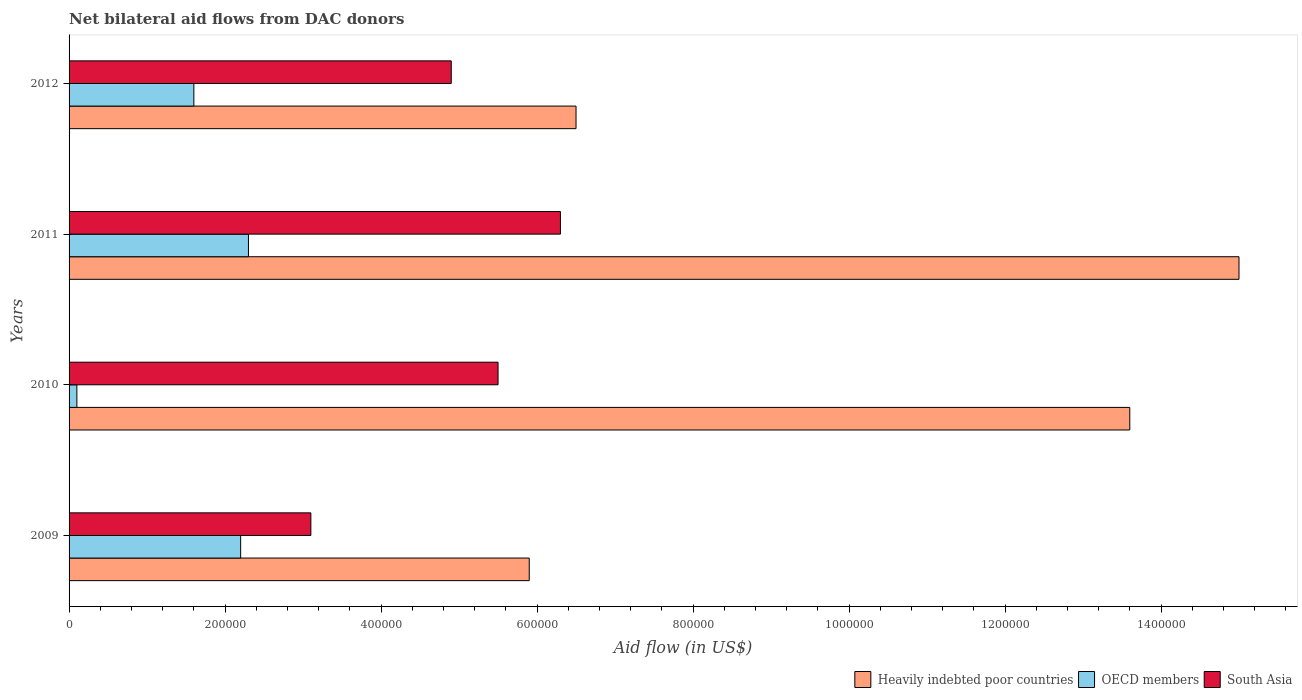How many groups of bars are there?
Your answer should be compact. 4. How many bars are there on the 1st tick from the bottom?
Give a very brief answer. 3. What is the net bilateral aid flow in Heavily indebted poor countries in 2009?
Provide a succinct answer. 5.90e+05. Across all years, what is the maximum net bilateral aid flow in South Asia?
Your response must be concise. 6.30e+05. Across all years, what is the minimum net bilateral aid flow in South Asia?
Make the answer very short. 3.10e+05. In which year was the net bilateral aid flow in OECD members maximum?
Your answer should be compact. 2011. In which year was the net bilateral aid flow in South Asia minimum?
Give a very brief answer. 2009. What is the total net bilateral aid flow in OECD members in the graph?
Your response must be concise. 6.20e+05. What is the difference between the net bilateral aid flow in South Asia in 2011 and that in 2012?
Give a very brief answer. 1.40e+05. What is the difference between the net bilateral aid flow in OECD members in 2010 and the net bilateral aid flow in Heavily indebted poor countries in 2011?
Provide a succinct answer. -1.49e+06. What is the average net bilateral aid flow in South Asia per year?
Your answer should be very brief. 4.95e+05. In the year 2010, what is the difference between the net bilateral aid flow in Heavily indebted poor countries and net bilateral aid flow in South Asia?
Offer a very short reply. 8.10e+05. In how many years, is the net bilateral aid flow in OECD members greater than 240000 US$?
Ensure brevity in your answer.  0. Is the net bilateral aid flow in Heavily indebted poor countries in 2011 less than that in 2012?
Give a very brief answer. No. Is the difference between the net bilateral aid flow in Heavily indebted poor countries in 2011 and 2012 greater than the difference between the net bilateral aid flow in South Asia in 2011 and 2012?
Offer a terse response. Yes. What is the difference between the highest and the lowest net bilateral aid flow in OECD members?
Offer a terse response. 2.20e+05. In how many years, is the net bilateral aid flow in South Asia greater than the average net bilateral aid flow in South Asia taken over all years?
Offer a terse response. 2. Are all the bars in the graph horizontal?
Your answer should be compact. Yes. How many years are there in the graph?
Give a very brief answer. 4. What is the difference between two consecutive major ticks on the X-axis?
Offer a very short reply. 2.00e+05. Does the graph contain grids?
Give a very brief answer. No. Where does the legend appear in the graph?
Make the answer very short. Bottom right. How many legend labels are there?
Provide a short and direct response. 3. How are the legend labels stacked?
Offer a very short reply. Horizontal. What is the title of the graph?
Give a very brief answer. Net bilateral aid flows from DAC donors. What is the label or title of the X-axis?
Make the answer very short. Aid flow (in US$). What is the Aid flow (in US$) in Heavily indebted poor countries in 2009?
Make the answer very short. 5.90e+05. What is the Aid flow (in US$) in South Asia in 2009?
Give a very brief answer. 3.10e+05. What is the Aid flow (in US$) of Heavily indebted poor countries in 2010?
Ensure brevity in your answer.  1.36e+06. What is the Aid flow (in US$) of South Asia in 2010?
Ensure brevity in your answer.  5.50e+05. What is the Aid flow (in US$) in Heavily indebted poor countries in 2011?
Ensure brevity in your answer.  1.50e+06. What is the Aid flow (in US$) in South Asia in 2011?
Offer a terse response. 6.30e+05. What is the Aid flow (in US$) in Heavily indebted poor countries in 2012?
Keep it short and to the point. 6.50e+05. Across all years, what is the maximum Aid flow (in US$) in Heavily indebted poor countries?
Provide a succinct answer. 1.50e+06. Across all years, what is the maximum Aid flow (in US$) of OECD members?
Give a very brief answer. 2.30e+05. Across all years, what is the maximum Aid flow (in US$) of South Asia?
Give a very brief answer. 6.30e+05. Across all years, what is the minimum Aid flow (in US$) of Heavily indebted poor countries?
Provide a succinct answer. 5.90e+05. Across all years, what is the minimum Aid flow (in US$) of South Asia?
Offer a very short reply. 3.10e+05. What is the total Aid flow (in US$) in Heavily indebted poor countries in the graph?
Make the answer very short. 4.10e+06. What is the total Aid flow (in US$) in OECD members in the graph?
Your answer should be compact. 6.20e+05. What is the total Aid flow (in US$) in South Asia in the graph?
Your answer should be compact. 1.98e+06. What is the difference between the Aid flow (in US$) of Heavily indebted poor countries in 2009 and that in 2010?
Offer a terse response. -7.70e+05. What is the difference between the Aid flow (in US$) in South Asia in 2009 and that in 2010?
Your answer should be compact. -2.40e+05. What is the difference between the Aid flow (in US$) of Heavily indebted poor countries in 2009 and that in 2011?
Give a very brief answer. -9.10e+05. What is the difference between the Aid flow (in US$) of OECD members in 2009 and that in 2011?
Your answer should be very brief. -10000. What is the difference between the Aid flow (in US$) in South Asia in 2009 and that in 2011?
Give a very brief answer. -3.20e+05. What is the difference between the Aid flow (in US$) in Heavily indebted poor countries in 2009 and that in 2012?
Keep it short and to the point. -6.00e+04. What is the difference between the Aid flow (in US$) in South Asia in 2009 and that in 2012?
Your answer should be compact. -1.80e+05. What is the difference between the Aid flow (in US$) in Heavily indebted poor countries in 2010 and that in 2011?
Your answer should be compact. -1.40e+05. What is the difference between the Aid flow (in US$) in Heavily indebted poor countries in 2010 and that in 2012?
Give a very brief answer. 7.10e+05. What is the difference between the Aid flow (in US$) in OECD members in 2010 and that in 2012?
Offer a terse response. -1.50e+05. What is the difference between the Aid flow (in US$) in South Asia in 2010 and that in 2012?
Offer a terse response. 6.00e+04. What is the difference between the Aid flow (in US$) of Heavily indebted poor countries in 2011 and that in 2012?
Your response must be concise. 8.50e+05. What is the difference between the Aid flow (in US$) of Heavily indebted poor countries in 2009 and the Aid flow (in US$) of OECD members in 2010?
Your answer should be very brief. 5.80e+05. What is the difference between the Aid flow (in US$) of OECD members in 2009 and the Aid flow (in US$) of South Asia in 2010?
Your answer should be very brief. -3.30e+05. What is the difference between the Aid flow (in US$) of Heavily indebted poor countries in 2009 and the Aid flow (in US$) of South Asia in 2011?
Make the answer very short. -4.00e+04. What is the difference between the Aid flow (in US$) of OECD members in 2009 and the Aid flow (in US$) of South Asia in 2011?
Offer a very short reply. -4.10e+05. What is the difference between the Aid flow (in US$) in Heavily indebted poor countries in 2009 and the Aid flow (in US$) in OECD members in 2012?
Give a very brief answer. 4.30e+05. What is the difference between the Aid flow (in US$) in OECD members in 2009 and the Aid flow (in US$) in South Asia in 2012?
Offer a terse response. -2.70e+05. What is the difference between the Aid flow (in US$) of Heavily indebted poor countries in 2010 and the Aid flow (in US$) of OECD members in 2011?
Give a very brief answer. 1.13e+06. What is the difference between the Aid flow (in US$) of Heavily indebted poor countries in 2010 and the Aid flow (in US$) of South Asia in 2011?
Give a very brief answer. 7.30e+05. What is the difference between the Aid flow (in US$) in OECD members in 2010 and the Aid flow (in US$) in South Asia in 2011?
Give a very brief answer. -6.20e+05. What is the difference between the Aid flow (in US$) of Heavily indebted poor countries in 2010 and the Aid flow (in US$) of OECD members in 2012?
Offer a very short reply. 1.20e+06. What is the difference between the Aid flow (in US$) of Heavily indebted poor countries in 2010 and the Aid flow (in US$) of South Asia in 2012?
Offer a very short reply. 8.70e+05. What is the difference between the Aid flow (in US$) of OECD members in 2010 and the Aid flow (in US$) of South Asia in 2012?
Your response must be concise. -4.80e+05. What is the difference between the Aid flow (in US$) in Heavily indebted poor countries in 2011 and the Aid flow (in US$) in OECD members in 2012?
Offer a terse response. 1.34e+06. What is the difference between the Aid flow (in US$) of Heavily indebted poor countries in 2011 and the Aid flow (in US$) of South Asia in 2012?
Offer a terse response. 1.01e+06. What is the average Aid flow (in US$) in Heavily indebted poor countries per year?
Provide a short and direct response. 1.02e+06. What is the average Aid flow (in US$) of OECD members per year?
Keep it short and to the point. 1.55e+05. What is the average Aid flow (in US$) of South Asia per year?
Keep it short and to the point. 4.95e+05. In the year 2009, what is the difference between the Aid flow (in US$) in Heavily indebted poor countries and Aid flow (in US$) in OECD members?
Make the answer very short. 3.70e+05. In the year 2009, what is the difference between the Aid flow (in US$) in Heavily indebted poor countries and Aid flow (in US$) in South Asia?
Your response must be concise. 2.80e+05. In the year 2010, what is the difference between the Aid flow (in US$) in Heavily indebted poor countries and Aid flow (in US$) in OECD members?
Provide a succinct answer. 1.35e+06. In the year 2010, what is the difference between the Aid flow (in US$) in Heavily indebted poor countries and Aid flow (in US$) in South Asia?
Provide a short and direct response. 8.10e+05. In the year 2010, what is the difference between the Aid flow (in US$) in OECD members and Aid flow (in US$) in South Asia?
Your answer should be very brief. -5.40e+05. In the year 2011, what is the difference between the Aid flow (in US$) in Heavily indebted poor countries and Aid flow (in US$) in OECD members?
Make the answer very short. 1.27e+06. In the year 2011, what is the difference between the Aid flow (in US$) in Heavily indebted poor countries and Aid flow (in US$) in South Asia?
Your response must be concise. 8.70e+05. In the year 2011, what is the difference between the Aid flow (in US$) in OECD members and Aid flow (in US$) in South Asia?
Provide a succinct answer. -4.00e+05. In the year 2012, what is the difference between the Aid flow (in US$) in Heavily indebted poor countries and Aid flow (in US$) in South Asia?
Give a very brief answer. 1.60e+05. In the year 2012, what is the difference between the Aid flow (in US$) of OECD members and Aid flow (in US$) of South Asia?
Provide a short and direct response. -3.30e+05. What is the ratio of the Aid flow (in US$) of Heavily indebted poor countries in 2009 to that in 2010?
Make the answer very short. 0.43. What is the ratio of the Aid flow (in US$) of OECD members in 2009 to that in 2010?
Your answer should be very brief. 22. What is the ratio of the Aid flow (in US$) in South Asia in 2009 to that in 2010?
Ensure brevity in your answer.  0.56. What is the ratio of the Aid flow (in US$) of Heavily indebted poor countries in 2009 to that in 2011?
Offer a terse response. 0.39. What is the ratio of the Aid flow (in US$) of OECD members in 2009 to that in 2011?
Provide a short and direct response. 0.96. What is the ratio of the Aid flow (in US$) of South Asia in 2009 to that in 2011?
Your answer should be very brief. 0.49. What is the ratio of the Aid flow (in US$) in Heavily indebted poor countries in 2009 to that in 2012?
Your answer should be very brief. 0.91. What is the ratio of the Aid flow (in US$) of OECD members in 2009 to that in 2012?
Your answer should be very brief. 1.38. What is the ratio of the Aid flow (in US$) in South Asia in 2009 to that in 2012?
Your answer should be very brief. 0.63. What is the ratio of the Aid flow (in US$) in Heavily indebted poor countries in 2010 to that in 2011?
Provide a succinct answer. 0.91. What is the ratio of the Aid flow (in US$) of OECD members in 2010 to that in 2011?
Your answer should be very brief. 0.04. What is the ratio of the Aid flow (in US$) of South Asia in 2010 to that in 2011?
Ensure brevity in your answer.  0.87. What is the ratio of the Aid flow (in US$) of Heavily indebted poor countries in 2010 to that in 2012?
Provide a succinct answer. 2.09. What is the ratio of the Aid flow (in US$) of OECD members in 2010 to that in 2012?
Give a very brief answer. 0.06. What is the ratio of the Aid flow (in US$) of South Asia in 2010 to that in 2012?
Give a very brief answer. 1.12. What is the ratio of the Aid flow (in US$) in Heavily indebted poor countries in 2011 to that in 2012?
Offer a terse response. 2.31. What is the ratio of the Aid flow (in US$) in OECD members in 2011 to that in 2012?
Ensure brevity in your answer.  1.44. What is the difference between the highest and the second highest Aid flow (in US$) of Heavily indebted poor countries?
Offer a very short reply. 1.40e+05. What is the difference between the highest and the second highest Aid flow (in US$) in South Asia?
Provide a short and direct response. 8.00e+04. What is the difference between the highest and the lowest Aid flow (in US$) of Heavily indebted poor countries?
Offer a terse response. 9.10e+05. What is the difference between the highest and the lowest Aid flow (in US$) of OECD members?
Your answer should be very brief. 2.20e+05. 